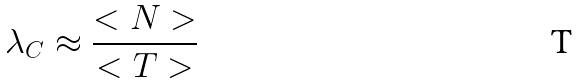Convert formula to latex. <formula><loc_0><loc_0><loc_500><loc_500>\lambda _ { C } \approx \frac { < N > } { < T > }</formula> 